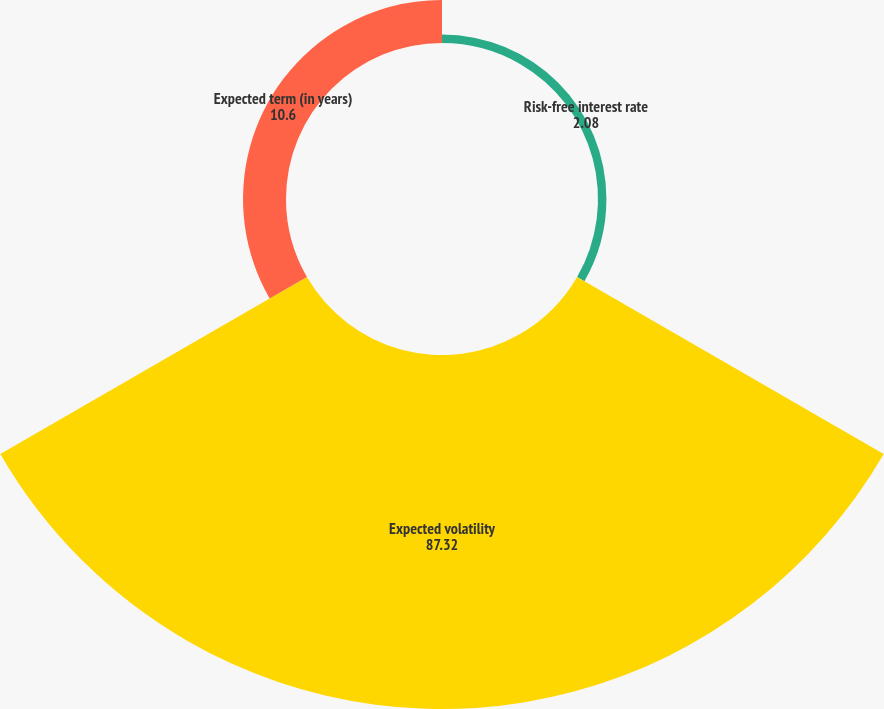Convert chart to OTSL. <chart><loc_0><loc_0><loc_500><loc_500><pie_chart><fcel>Risk-free interest rate<fcel>Expected volatility<fcel>Expected term (in years)<nl><fcel>2.08%<fcel>87.32%<fcel>10.6%<nl></chart> 